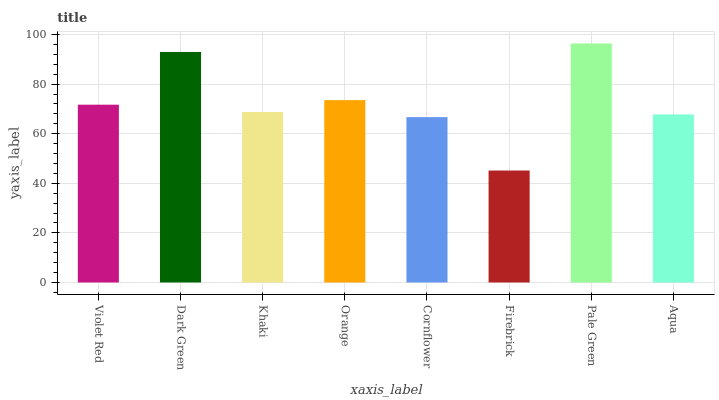Is Firebrick the minimum?
Answer yes or no. Yes. Is Pale Green the maximum?
Answer yes or no. Yes. Is Dark Green the minimum?
Answer yes or no. No. Is Dark Green the maximum?
Answer yes or no. No. Is Dark Green greater than Violet Red?
Answer yes or no. Yes. Is Violet Red less than Dark Green?
Answer yes or no. Yes. Is Violet Red greater than Dark Green?
Answer yes or no. No. Is Dark Green less than Violet Red?
Answer yes or no. No. Is Violet Red the high median?
Answer yes or no. Yes. Is Khaki the low median?
Answer yes or no. Yes. Is Orange the high median?
Answer yes or no. No. Is Orange the low median?
Answer yes or no. No. 